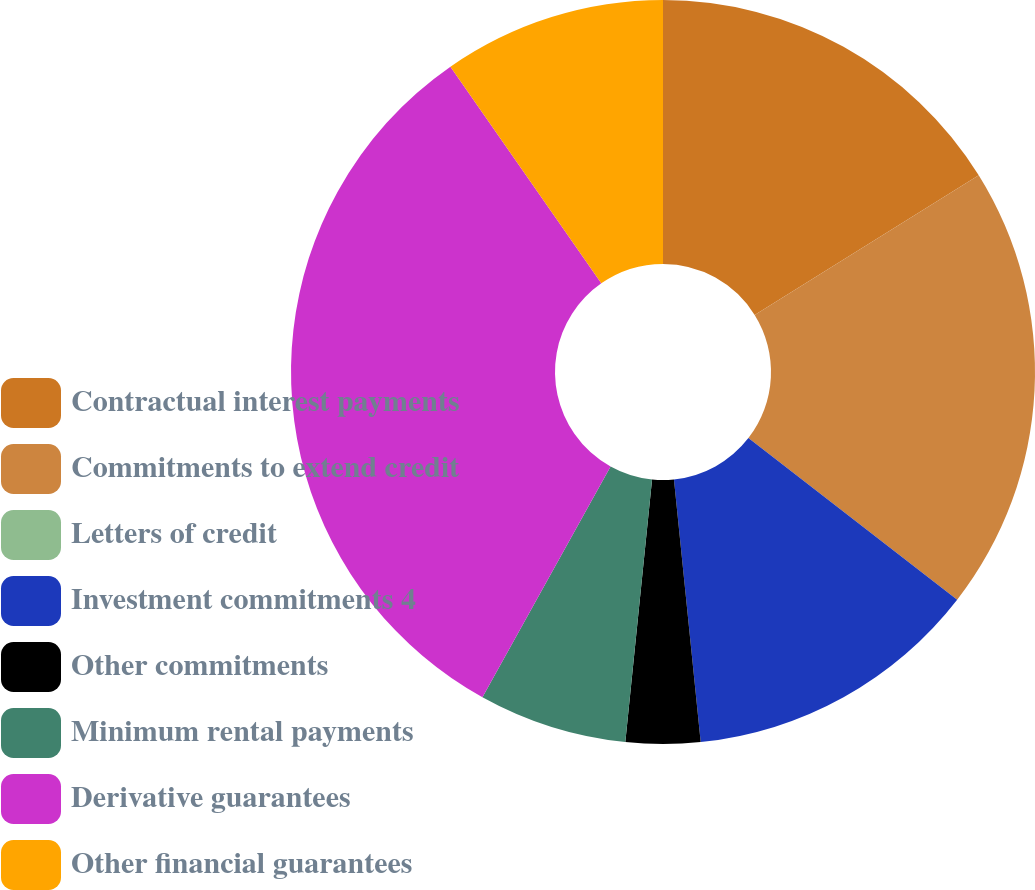<chart> <loc_0><loc_0><loc_500><loc_500><pie_chart><fcel>Contractual interest payments<fcel>Commitments to extend credit<fcel>Letters of credit<fcel>Investment commitments 4<fcel>Other commitments<fcel>Minimum rental payments<fcel>Derivative guarantees<fcel>Other financial guarantees<nl><fcel>16.13%<fcel>19.35%<fcel>0.0%<fcel>12.9%<fcel>3.23%<fcel>6.45%<fcel>32.25%<fcel>9.68%<nl></chart> 